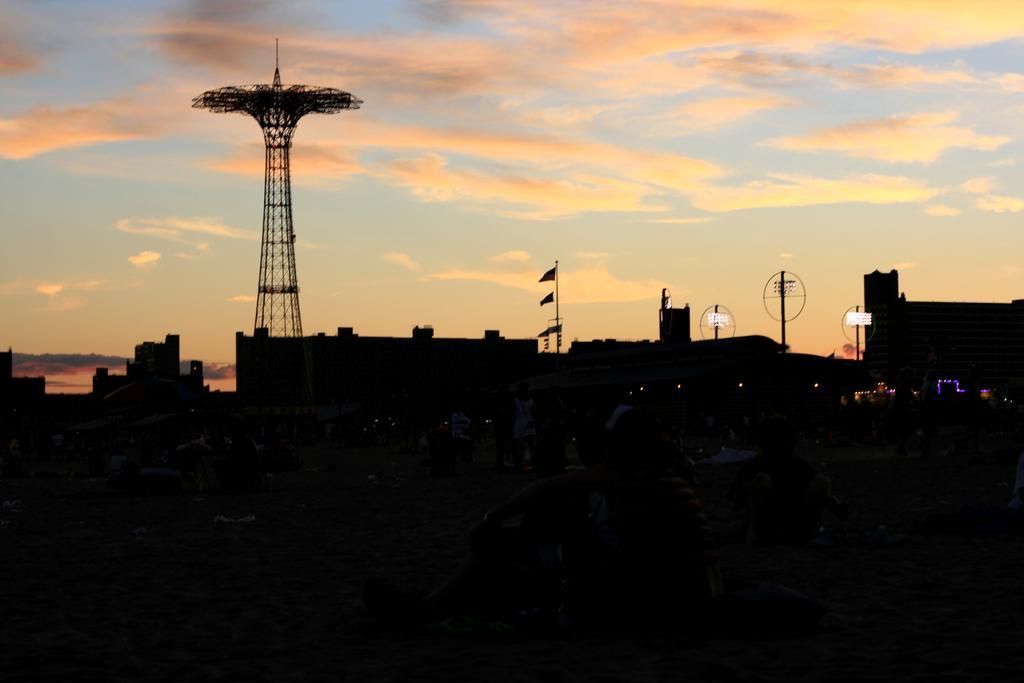In one or two sentences, can you explain what this image depicts? At the bottom the image is dark but we can see few persons are sitting and standing on the sand and there are other objects. In the background there are buildings,poles,flags,tower,lights and clouds in the sky. 